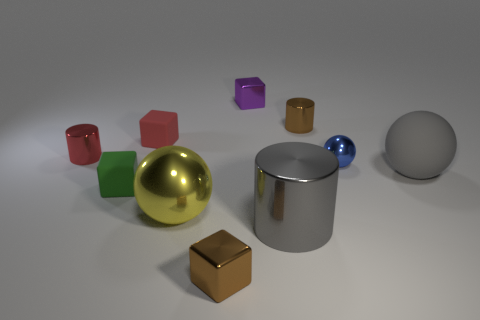How many other things are the same shape as the large gray shiny object?
Offer a terse response. 2. How many objects are either brown metallic objects that are behind the small blue shiny sphere or tiny shiny blocks behind the red metal cylinder?
Provide a short and direct response. 2. What is the size of the cylinder that is both in front of the brown cylinder and to the right of the tiny purple cube?
Your answer should be very brief. Large. There is a brown metal thing that is on the left side of the big gray shiny cylinder; is it the same shape as the tiny red metal object?
Offer a terse response. No. There is a sphere that is on the left side of the tiny brown thing that is on the right side of the tiny metallic block that is behind the small metal sphere; how big is it?
Provide a succinct answer. Large. There is a sphere that is the same color as the large cylinder; what is its size?
Your answer should be compact. Large. What number of things are either big purple shiny cylinders or tiny blue metal objects?
Your answer should be very brief. 1. There is a tiny thing that is both in front of the tiny sphere and on the right side of the yellow thing; what shape is it?
Your answer should be compact. Cube. Is the shape of the tiny green thing the same as the big shiny thing that is on the right side of the big yellow thing?
Make the answer very short. No. Are there any shiny spheres left of the large gray metallic thing?
Your response must be concise. Yes. 